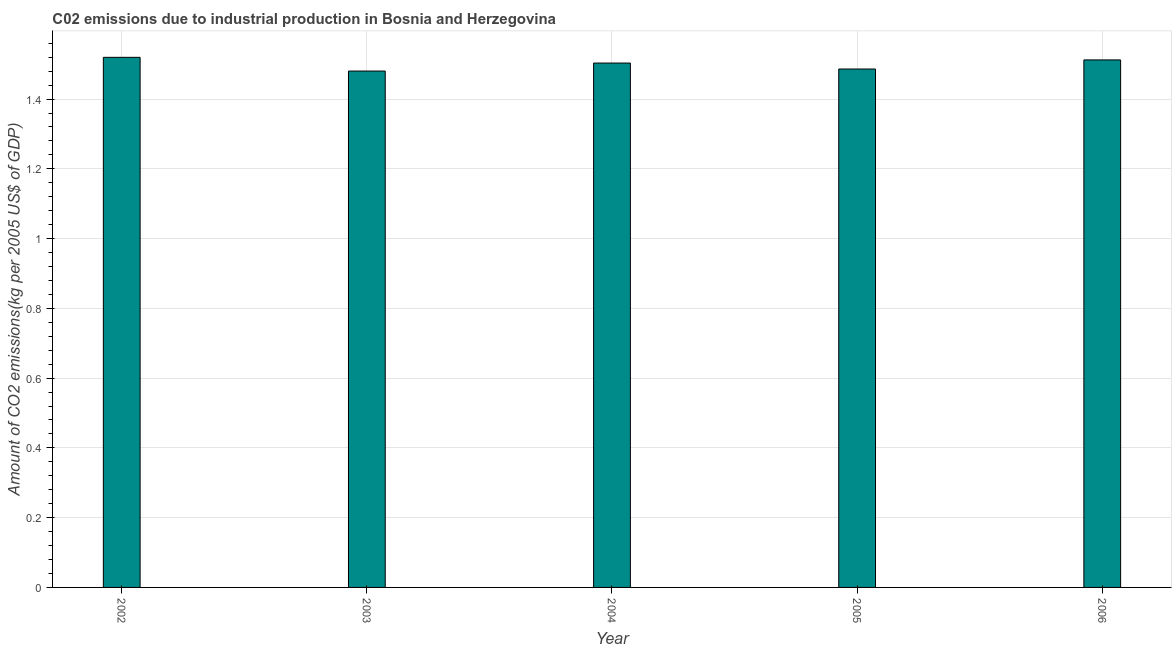Does the graph contain grids?
Your answer should be compact. Yes. What is the title of the graph?
Provide a succinct answer. C02 emissions due to industrial production in Bosnia and Herzegovina. What is the label or title of the Y-axis?
Make the answer very short. Amount of CO2 emissions(kg per 2005 US$ of GDP). What is the amount of co2 emissions in 2006?
Offer a very short reply. 1.51. Across all years, what is the maximum amount of co2 emissions?
Your answer should be compact. 1.52. Across all years, what is the minimum amount of co2 emissions?
Make the answer very short. 1.48. In which year was the amount of co2 emissions maximum?
Ensure brevity in your answer.  2002. In which year was the amount of co2 emissions minimum?
Your response must be concise. 2003. What is the sum of the amount of co2 emissions?
Your answer should be compact. 7.5. What is the difference between the amount of co2 emissions in 2002 and 2005?
Offer a very short reply. 0.03. What is the average amount of co2 emissions per year?
Offer a terse response. 1.5. What is the median amount of co2 emissions?
Your answer should be very brief. 1.5. Is the amount of co2 emissions in 2004 less than that in 2005?
Offer a terse response. No. What is the difference between the highest and the second highest amount of co2 emissions?
Provide a succinct answer. 0.01. Is the sum of the amount of co2 emissions in 2005 and 2006 greater than the maximum amount of co2 emissions across all years?
Keep it short and to the point. Yes. What is the difference between the highest and the lowest amount of co2 emissions?
Offer a terse response. 0.04. How many bars are there?
Your answer should be very brief. 5. Are all the bars in the graph horizontal?
Offer a terse response. No. Are the values on the major ticks of Y-axis written in scientific E-notation?
Keep it short and to the point. No. What is the Amount of CO2 emissions(kg per 2005 US$ of GDP) of 2002?
Your response must be concise. 1.52. What is the Amount of CO2 emissions(kg per 2005 US$ of GDP) of 2003?
Offer a very short reply. 1.48. What is the Amount of CO2 emissions(kg per 2005 US$ of GDP) in 2004?
Offer a very short reply. 1.5. What is the Amount of CO2 emissions(kg per 2005 US$ of GDP) of 2005?
Ensure brevity in your answer.  1.49. What is the Amount of CO2 emissions(kg per 2005 US$ of GDP) in 2006?
Provide a short and direct response. 1.51. What is the difference between the Amount of CO2 emissions(kg per 2005 US$ of GDP) in 2002 and 2003?
Give a very brief answer. 0.04. What is the difference between the Amount of CO2 emissions(kg per 2005 US$ of GDP) in 2002 and 2004?
Provide a succinct answer. 0.02. What is the difference between the Amount of CO2 emissions(kg per 2005 US$ of GDP) in 2002 and 2005?
Make the answer very short. 0.03. What is the difference between the Amount of CO2 emissions(kg per 2005 US$ of GDP) in 2002 and 2006?
Provide a succinct answer. 0.01. What is the difference between the Amount of CO2 emissions(kg per 2005 US$ of GDP) in 2003 and 2004?
Keep it short and to the point. -0.02. What is the difference between the Amount of CO2 emissions(kg per 2005 US$ of GDP) in 2003 and 2005?
Ensure brevity in your answer.  -0.01. What is the difference between the Amount of CO2 emissions(kg per 2005 US$ of GDP) in 2003 and 2006?
Keep it short and to the point. -0.03. What is the difference between the Amount of CO2 emissions(kg per 2005 US$ of GDP) in 2004 and 2005?
Your response must be concise. 0.02. What is the difference between the Amount of CO2 emissions(kg per 2005 US$ of GDP) in 2004 and 2006?
Offer a very short reply. -0.01. What is the difference between the Amount of CO2 emissions(kg per 2005 US$ of GDP) in 2005 and 2006?
Your answer should be very brief. -0.03. What is the ratio of the Amount of CO2 emissions(kg per 2005 US$ of GDP) in 2002 to that in 2003?
Make the answer very short. 1.03. What is the ratio of the Amount of CO2 emissions(kg per 2005 US$ of GDP) in 2002 to that in 2005?
Give a very brief answer. 1.02. What is the ratio of the Amount of CO2 emissions(kg per 2005 US$ of GDP) in 2002 to that in 2006?
Make the answer very short. 1. What is the ratio of the Amount of CO2 emissions(kg per 2005 US$ of GDP) in 2004 to that in 2005?
Make the answer very short. 1.01. What is the ratio of the Amount of CO2 emissions(kg per 2005 US$ of GDP) in 2004 to that in 2006?
Your answer should be compact. 0.99. What is the ratio of the Amount of CO2 emissions(kg per 2005 US$ of GDP) in 2005 to that in 2006?
Your response must be concise. 0.98. 